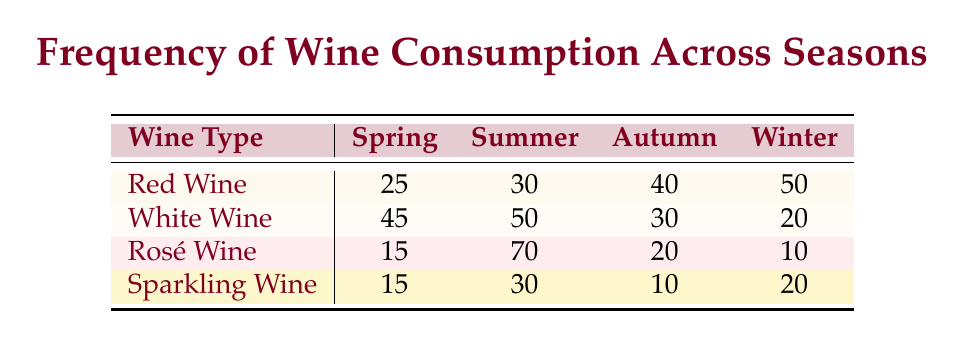What is the frequency of red wine consumption in summer? According to the table, the frequency of red wine consumption specifically during the summer season is provided as 30.
Answer: 30 Which season has the highest consumption of white wine? The table indicates that the highest frequency of white wine consumption occurs during the summer season, with a value of 50.
Answer: Summer What is the total frequency of rosé wine consumed across all seasons? By adding the values for rosé wine from each season: 15 (Spring) + 70 (Summer) + 20 (Autumn) + 10 (Winter) = 115.
Answer: 115 Is the frequency of sparkling wine consumption higher in winter than in autumn? The consumption of sparkling wine in winter is 20, while in autumn it is 10. Since 20 is greater than 10, the statement is true.
Answer: Yes What is the average frequency of red wine consumption across all seasons? To find the average, first sum the frequencies: 25 (Spring) + 30 (Summer) + 40 (Autumn) + 50 (Winter) = 145. Then divide this total by the number of seasons (4): 145/4 = 36.25.
Answer: 36.25 During which season does most people prefer rosé wine compared to other types? In the summer season, rosé wine has a frequency of 70, which is higher than all other types in that season: Red (30), White (50), and Sparkling (30). Thus, it is preferred in summer.
Answer: Summer What is the difference in frequency between red and white wine consumption in autumn? In autumn, red wine consumption is 40 and white wine consumption is 30. The difference is calculated by subtracting the white wine frequency from the red wine frequency: 40 - 30 = 10.
Answer: 10 Is the frequency of white wine consumption greater than or equal to that of sparkling wine consumption in any season? Checking the frequencies season by season: Spring (45 vs 15), Summer (50 vs 30), Autumn (30 vs 10), and Winter (20 vs 20). The condition is true for all seasons except for Winter, where they are equal.
Answer: Yes In which season do people consume the least amount of white wine? The table indicates that winter has the lowest frequency of white wine consumption at 20, compared to 45 in Spring, 50 in Summer, and 30 in Autumn.
Answer: Winter 